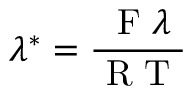<formula> <loc_0><loc_0><loc_500><loc_500>\lambda ^ { * } = \frac { F \lambda } { R T }</formula> 